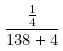<formula> <loc_0><loc_0><loc_500><loc_500>\frac { \frac { 1 } { 4 } } { 1 3 8 + 4 }</formula> 